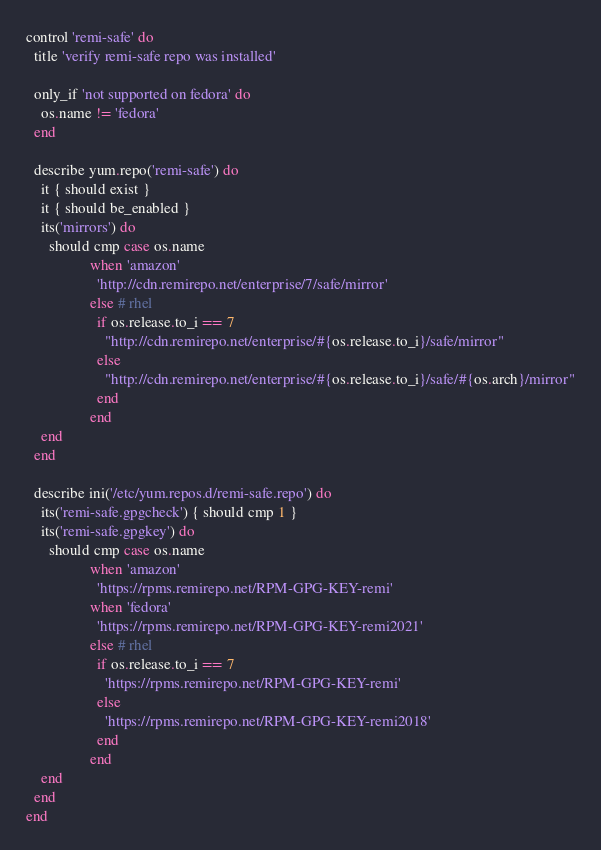Convert code to text. <code><loc_0><loc_0><loc_500><loc_500><_Ruby_>control 'remi-safe' do
  title 'verify remi-safe repo was installed'

  only_if 'not supported on fedora' do
    os.name != 'fedora'
  end

  describe yum.repo('remi-safe') do
    it { should exist }
    it { should be_enabled }
    its('mirrors') do
      should cmp case os.name
                 when 'amazon'
                   'http://cdn.remirepo.net/enterprise/7/safe/mirror'
                 else # rhel
                   if os.release.to_i == 7
                     "http://cdn.remirepo.net/enterprise/#{os.release.to_i}/safe/mirror"
                   else
                     "http://cdn.remirepo.net/enterprise/#{os.release.to_i}/safe/#{os.arch}/mirror"
                   end
                 end
    end
  end

  describe ini('/etc/yum.repos.d/remi-safe.repo') do
    its('remi-safe.gpgcheck') { should cmp 1 }
    its('remi-safe.gpgkey') do
      should cmp case os.name
                 when 'amazon'
                   'https://rpms.remirepo.net/RPM-GPG-KEY-remi'
                 when 'fedora'
                   'https://rpms.remirepo.net/RPM-GPG-KEY-remi2021'
                 else # rhel
                   if os.release.to_i == 7
                     'https://rpms.remirepo.net/RPM-GPG-KEY-remi'
                   else
                     'https://rpms.remirepo.net/RPM-GPG-KEY-remi2018'
                   end
                 end
    end
  end
end
</code> 